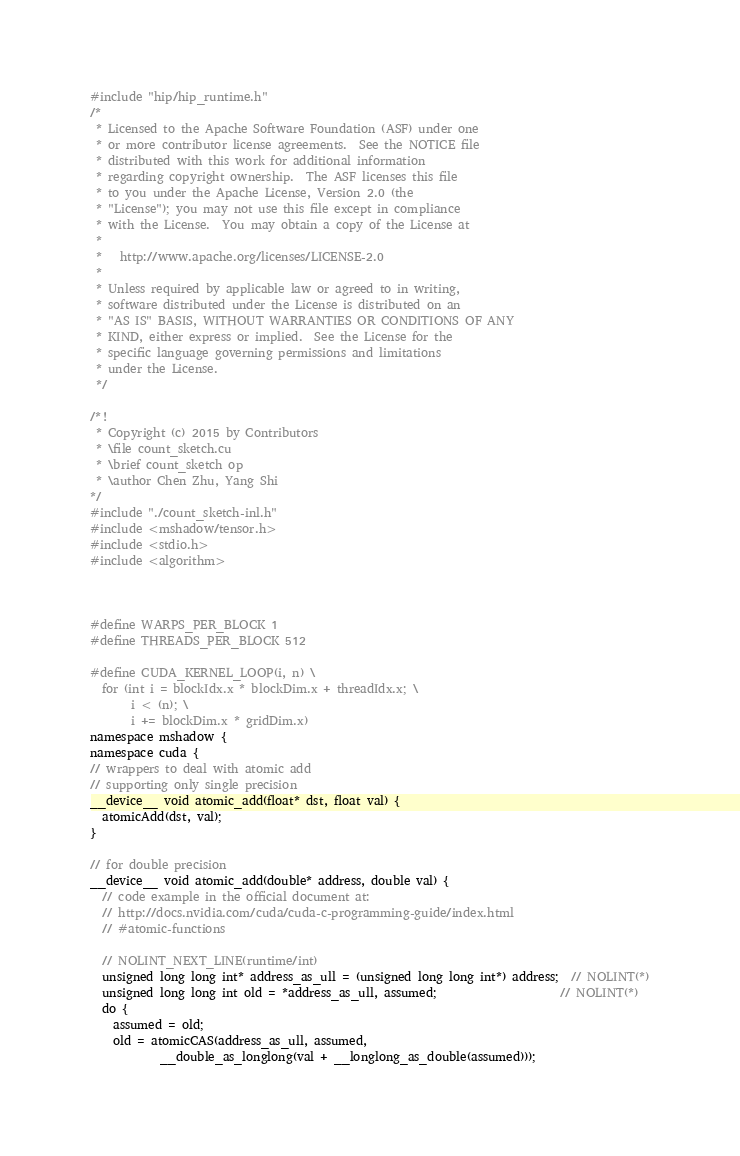<code> <loc_0><loc_0><loc_500><loc_500><_Cuda_>#include "hip/hip_runtime.h"
/*
 * Licensed to the Apache Software Foundation (ASF) under one
 * or more contributor license agreements.  See the NOTICE file
 * distributed with this work for additional information
 * regarding copyright ownership.  The ASF licenses this file
 * to you under the Apache License, Version 2.0 (the
 * "License"); you may not use this file except in compliance
 * with the License.  You may obtain a copy of the License at
 *
 *   http://www.apache.org/licenses/LICENSE-2.0
 *
 * Unless required by applicable law or agreed to in writing,
 * software distributed under the License is distributed on an
 * "AS IS" BASIS, WITHOUT WARRANTIES OR CONDITIONS OF ANY
 * KIND, either express or implied.  See the License for the
 * specific language governing permissions and limitations
 * under the License.
 */

/*!
 * Copyright (c) 2015 by Contributors
 * \file count_sketch.cu
 * \brief count_sketch op
 * \author Chen Zhu, Yang Shi
*/
#include "./count_sketch-inl.h"
#include <mshadow/tensor.h>
#include <stdio.h>
#include <algorithm>



#define WARPS_PER_BLOCK 1
#define THREADS_PER_BLOCK 512

#define CUDA_KERNEL_LOOP(i, n) \
  for (int i = blockIdx.x * blockDim.x + threadIdx.x; \
       i < (n); \
       i += blockDim.x * gridDim.x)
namespace mshadow {
namespace cuda {
// wrappers to deal with atomic add
// supporting only single precision
__device__ void atomic_add(float* dst, float val) {
  atomicAdd(dst, val);
}

// for double precision
__device__ void atomic_add(double* address, double val) {
  // code example in the official document at:
  // http://docs.nvidia.com/cuda/cuda-c-programming-guide/index.html
  // #atomic-functions

  // NOLINT_NEXT_LINE(runtime/int)
  unsigned long long int* address_as_ull = (unsigned long long int*) address;  // NOLINT(*)
  unsigned long long int old = *address_as_ull, assumed;                     // NOLINT(*)
  do {
    assumed = old;
    old = atomicCAS(address_as_ull, assumed,
            __double_as_longlong(val + __longlong_as_double(assumed)));</code> 